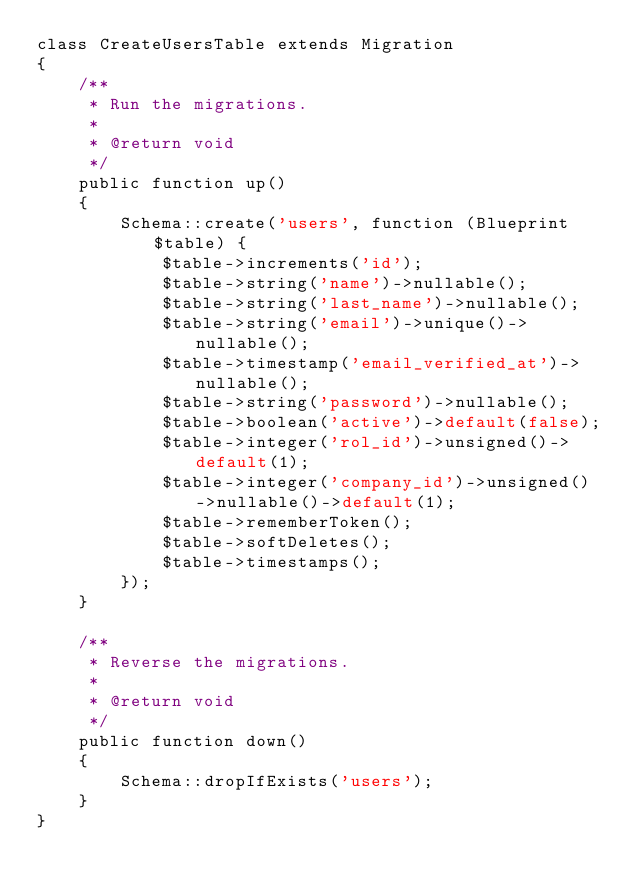Convert code to text. <code><loc_0><loc_0><loc_500><loc_500><_PHP_>class CreateUsersTable extends Migration
{
    /**
     * Run the migrations.
     *
     * @return void
     */
    public function up()
    {
        Schema::create('users', function (Blueprint $table) {
            $table->increments('id');
            $table->string('name')->nullable();
            $table->string('last_name')->nullable();
            $table->string('email')->unique()->nullable();
            $table->timestamp('email_verified_at')->nullable();
            $table->string('password')->nullable();
            $table->boolean('active')->default(false);
            $table->integer('rol_id')->unsigned()->default(1);
            $table->integer('company_id')->unsigned()->nullable()->default(1);
            $table->rememberToken();
            $table->softDeletes();
            $table->timestamps();
        });
    }

    /**
     * Reverse the migrations.
     *
     * @return void
     */
    public function down()
    {
        Schema::dropIfExists('users');
    }
}
</code> 